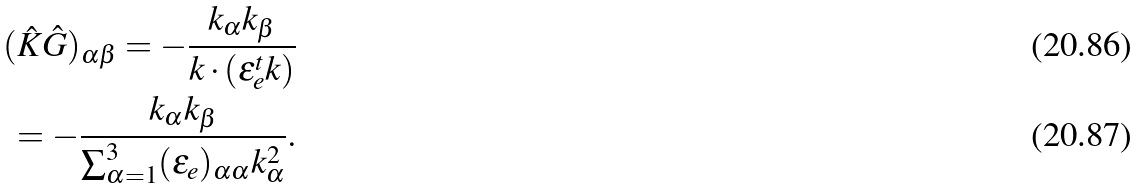<formula> <loc_0><loc_0><loc_500><loc_500>( \hat { K } \hat { G } ) _ { \alpha \beta } = - \frac { k _ { \alpha } k _ { \beta } } { { k } \cdot ( \varepsilon ^ { t } _ { e } { k } ) } \\ = - \frac { k _ { \alpha } k _ { \beta } } { \sum _ { \alpha = 1 } ^ { 3 } ( \varepsilon _ { e } ) _ { \alpha \alpha } k _ { \alpha } ^ { 2 } } .</formula> 